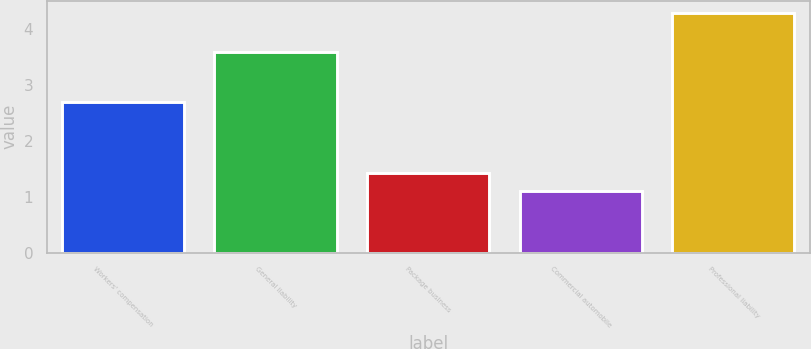Convert chart. <chart><loc_0><loc_0><loc_500><loc_500><bar_chart><fcel>Workers' compensation<fcel>General liability<fcel>Package business<fcel>Commercial automobile<fcel>Professional liability<nl><fcel>2.7<fcel>3.6<fcel>1.42<fcel>1.1<fcel>4.3<nl></chart> 